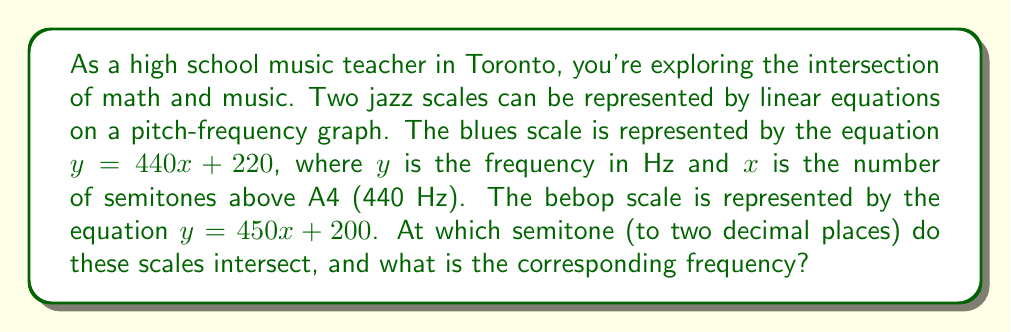Solve this math problem. To find the intersection point of these two scales, we need to solve the system of equations:

$$\begin{cases}
y = 440x + 220 \\
y = 450x + 200
\end{cases}$$

1) Since both equations equal $y$, we can set them equal to each other:

   $440x + 220 = 450x + 200$

2) Subtract $440x$ from both sides:

   $220 = 10x + 200$

3) Subtract 200 from both sides:

   $20 = 10x$

4) Divide both sides by 10:

   $2 = x$

5) Now that we know $x$, we can substitute it into either equation to find $y$. Let's use the blues scale equation:

   $y = 440(2) + 220$
   $y = 880 + 220 = 1100$

6) Therefore, the scales intersect at $x = 2$ semitones and $y = 1100$ Hz.

To convert the semitone value to two decimal places: $2.00$ semitones.
Answer: The scales intersect at 2.00 semitones above A4, with a frequency of 1100 Hz. 